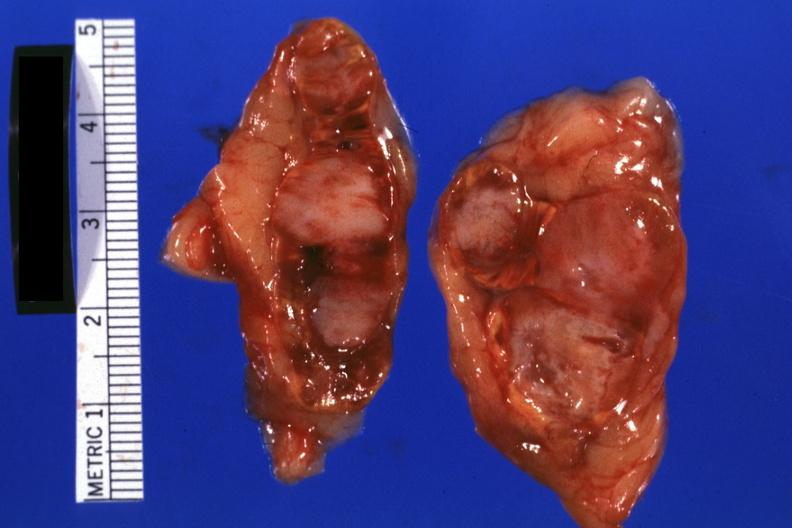where does this belong to?
Answer the question using a single word or phrase. Endocrine system 